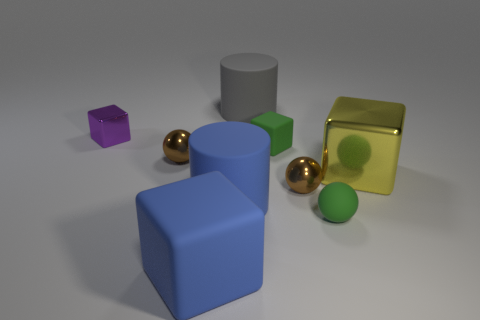Does the small matte ball have the same color as the tiny rubber cube?
Provide a short and direct response. Yes. There is a brown object on the right side of the gray cylinder that is behind the large yellow shiny thing; what number of brown balls are behind it?
Make the answer very short. 1. What material is the big thing to the right of the large cylinder behind the small purple metallic cube made of?
Your response must be concise. Metal. Is there a big blue thing that has the same shape as the yellow metal thing?
Provide a short and direct response. Yes. What is the color of the shiny block that is the same size as the rubber ball?
Your answer should be compact. Purple. What number of things are brown metallic things in front of the large yellow shiny cube or metal objects on the right side of the tiny purple object?
Your response must be concise. 3. How many things are either small purple shiny objects or large cyan rubber spheres?
Provide a short and direct response. 1. What is the size of the matte object that is behind the yellow object and left of the green block?
Your answer should be compact. Large. How many other cylinders have the same material as the blue cylinder?
Your answer should be very brief. 1. There is a tiny sphere that is the same material as the tiny green cube; what is its color?
Your response must be concise. Green. 